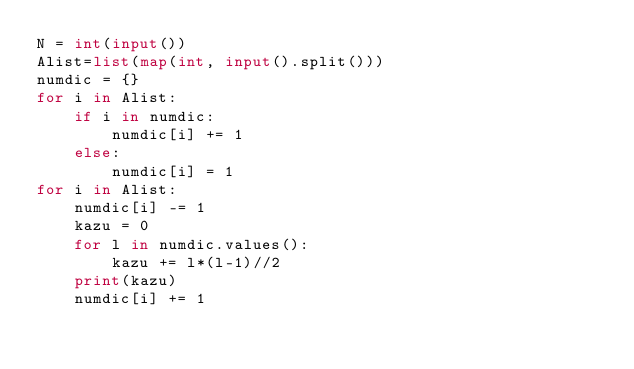Convert code to text. <code><loc_0><loc_0><loc_500><loc_500><_Python_>N = int(input())
Alist=list(map(int, input().split()))
numdic = {}
for i in Alist:
    if i in numdic:
        numdic[i] += 1
    else:
        numdic[i] = 1
for i in Alist:
    numdic[i] -= 1
    kazu = 0
    for l in numdic.values():
        kazu += l*(l-1)//2
    print(kazu)
    numdic[i] += 1</code> 